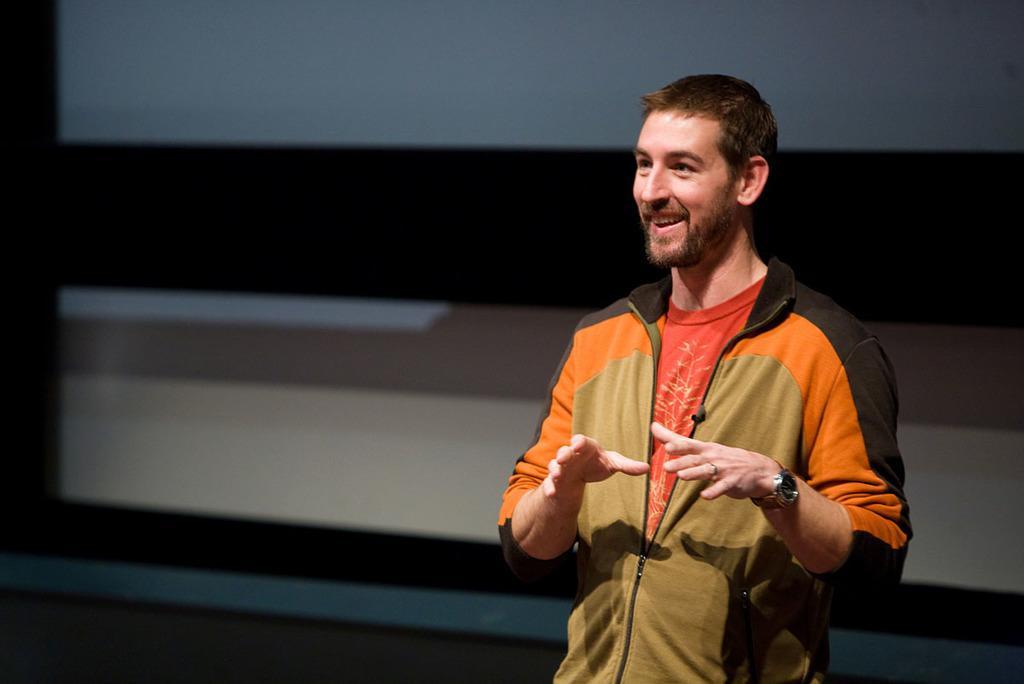How would you summarize this image in a sentence or two? In the foreground of this image, there is a man standing and he looks like he is talking something. In the background, we can see the wall. 